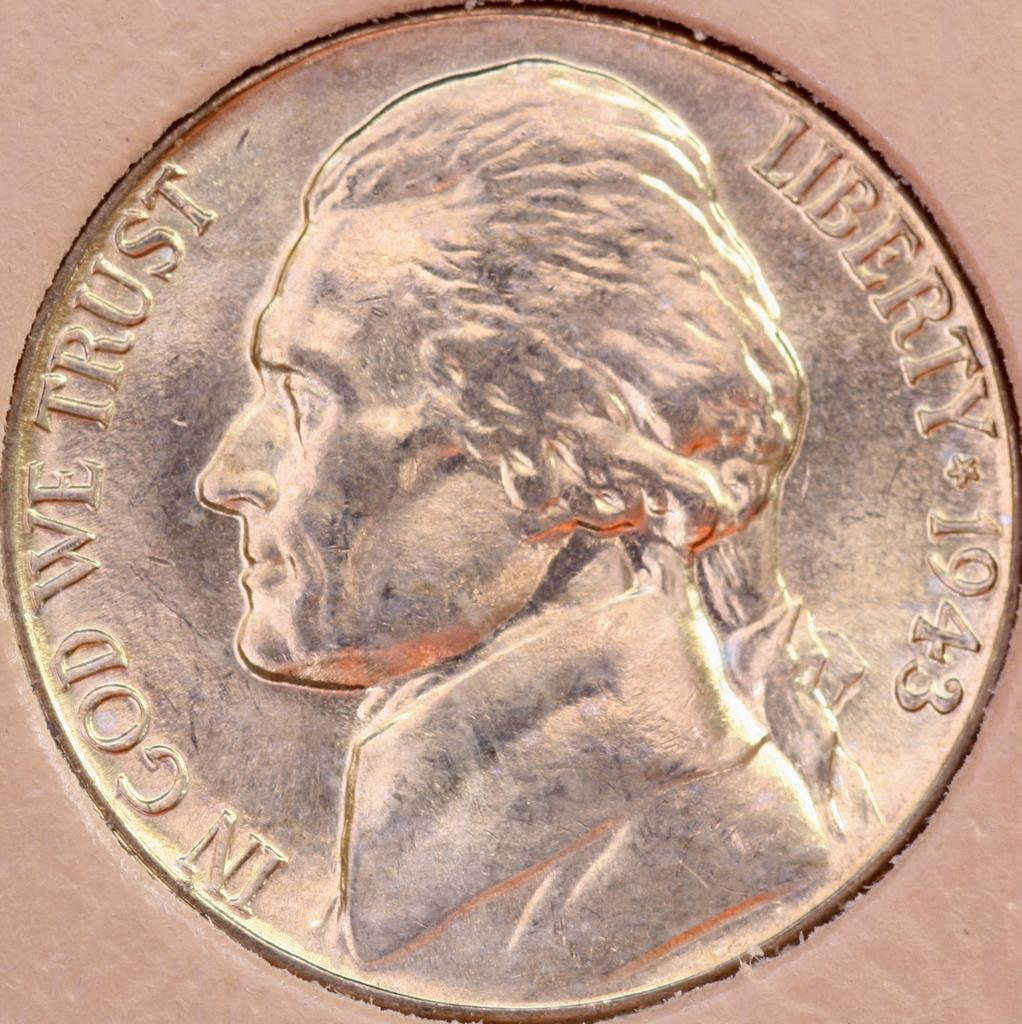<image>
Present a compact description of the photo's key features. Liberty 1943 is etched into the side of this coin. 